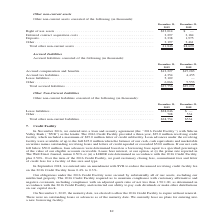According to A10 Networks's financial document, What is the total accrued liabilities as at 31 December 2018? According to the financial document, $25,291 (in thousands). The relevant text states: "Total accrued liabilities. . $27,756 $25,291..." Also, What is the total accrued liabilities as at 31 December 2019? According to the financial document, $27,756 (in thousands). The relevant text states: "Total accrued liabilities. . $27,756 $25,291..." Also, What is the units that the values in the table are measured in? According to the financial document, in thousands. The relevant text states: "er non-current assets consisted of the following (in thousands):..." Also, can you calculate: What is the percentage change in total accrued liabilities between 2018 and 2019? To answer this question, I need to perform calculations using the financial data. The calculation is: (27,756 - 25,291)/25,291 , which equals 9.75 (percentage). This is based on the information: "Total accrued liabilities. . $27,756 $25,291 Total accrued liabilities. . $27,756 $25,291..." The key data points involved are: 25,291, 27,756. Also, can you calculate: What is the percentage change in total accrued liabilities between 2018 and 2019? Based on the calculation: 27,756-25,291, the result is 2465 (in thousands). This is based on the information: "Total accrued liabilities. . $27,756 $25,291 Total accrued liabilities. . $27,756 $25,291..." The key data points involved are: 25,291, 27,756. Also, can you calculate: What is the total accrued tax liabilities between 2018 and 2019? Based on the calculation: 4,354 + 4,455 , the result is 8809 (in thousands). This is based on the information: "its. . $12,227 $15,283 Accrued tax liabilities. . 4,354 4,455 Lease liabilities . 5,109 — Other . 6,066 5,553 $12,227 $15,283 Accrued tax liabilities. . 4,354 4,455 Lease liabilities . 5,109 — Other ...." The key data points involved are: 4,354, 4,455. 